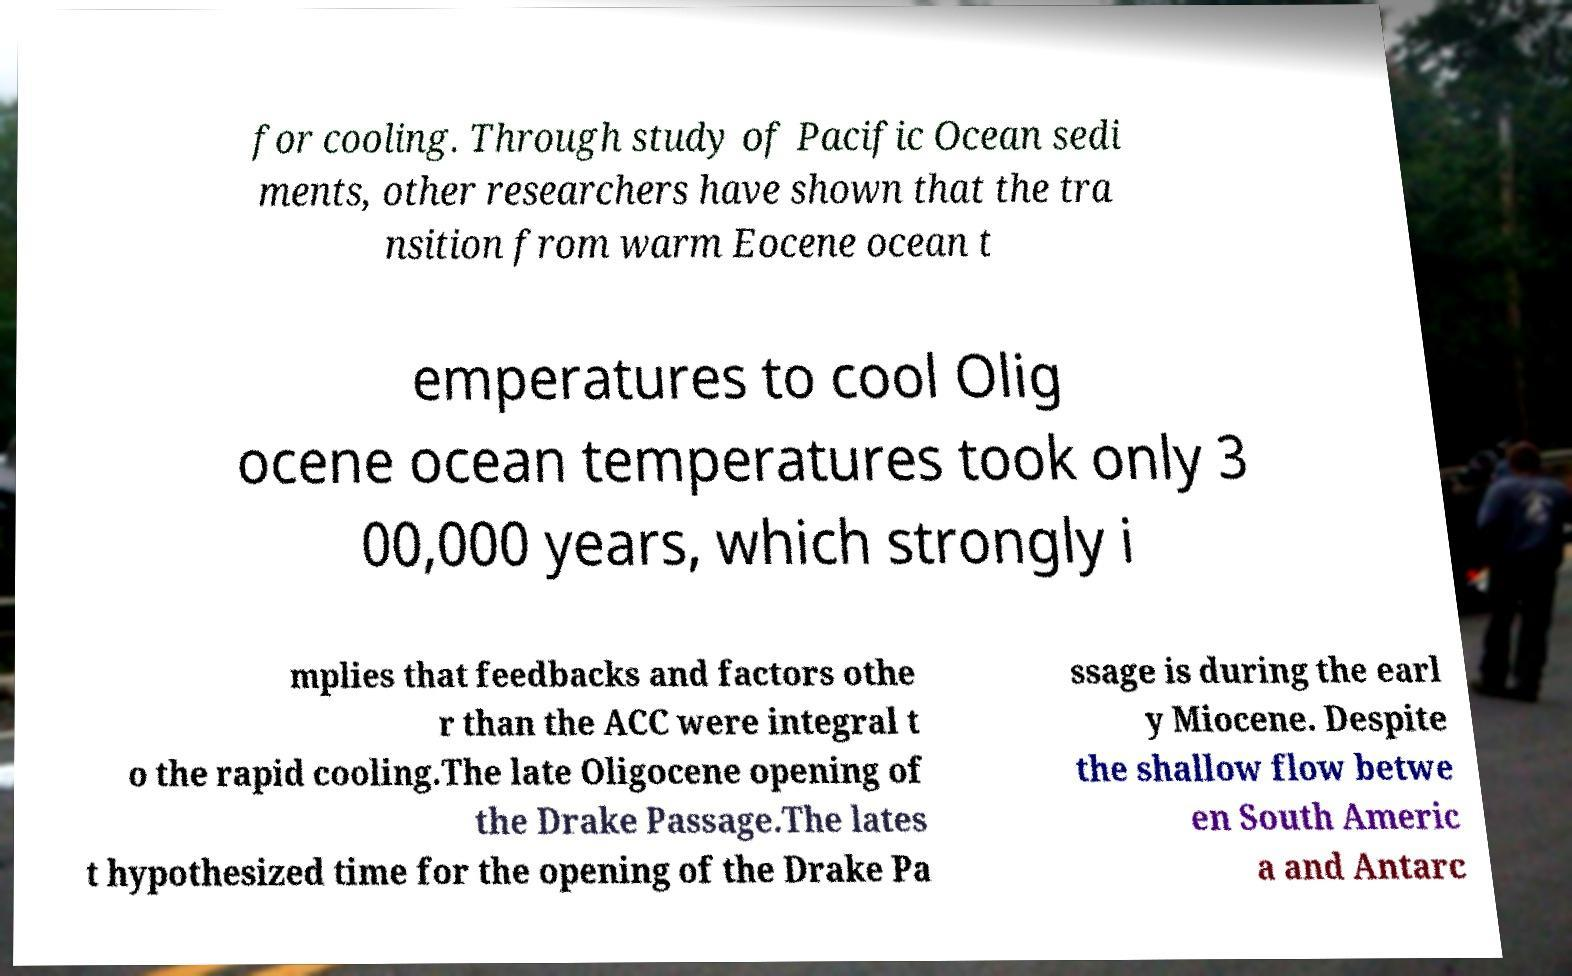What messages or text are displayed in this image? I need them in a readable, typed format. for cooling. Through study of Pacific Ocean sedi ments, other researchers have shown that the tra nsition from warm Eocene ocean t emperatures to cool Olig ocene ocean temperatures took only 3 00,000 years, which strongly i mplies that feedbacks and factors othe r than the ACC were integral t o the rapid cooling.The late Oligocene opening of the Drake Passage.The lates t hypothesized time for the opening of the Drake Pa ssage is during the earl y Miocene. Despite the shallow flow betwe en South Americ a and Antarc 